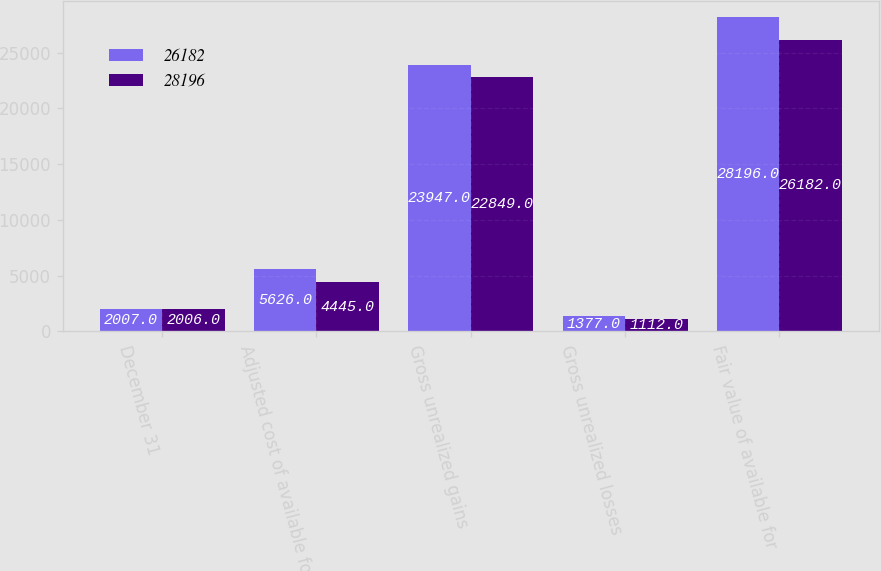Convert chart to OTSL. <chart><loc_0><loc_0><loc_500><loc_500><stacked_bar_chart><ecel><fcel>December 31<fcel>Adjusted cost of available for<fcel>Gross unrealized gains<fcel>Gross unrealized losses<fcel>Fair value of available for<nl><fcel>26182<fcel>2007<fcel>5626<fcel>23947<fcel>1377<fcel>28196<nl><fcel>28196<fcel>2006<fcel>4445<fcel>22849<fcel>1112<fcel>26182<nl></chart> 